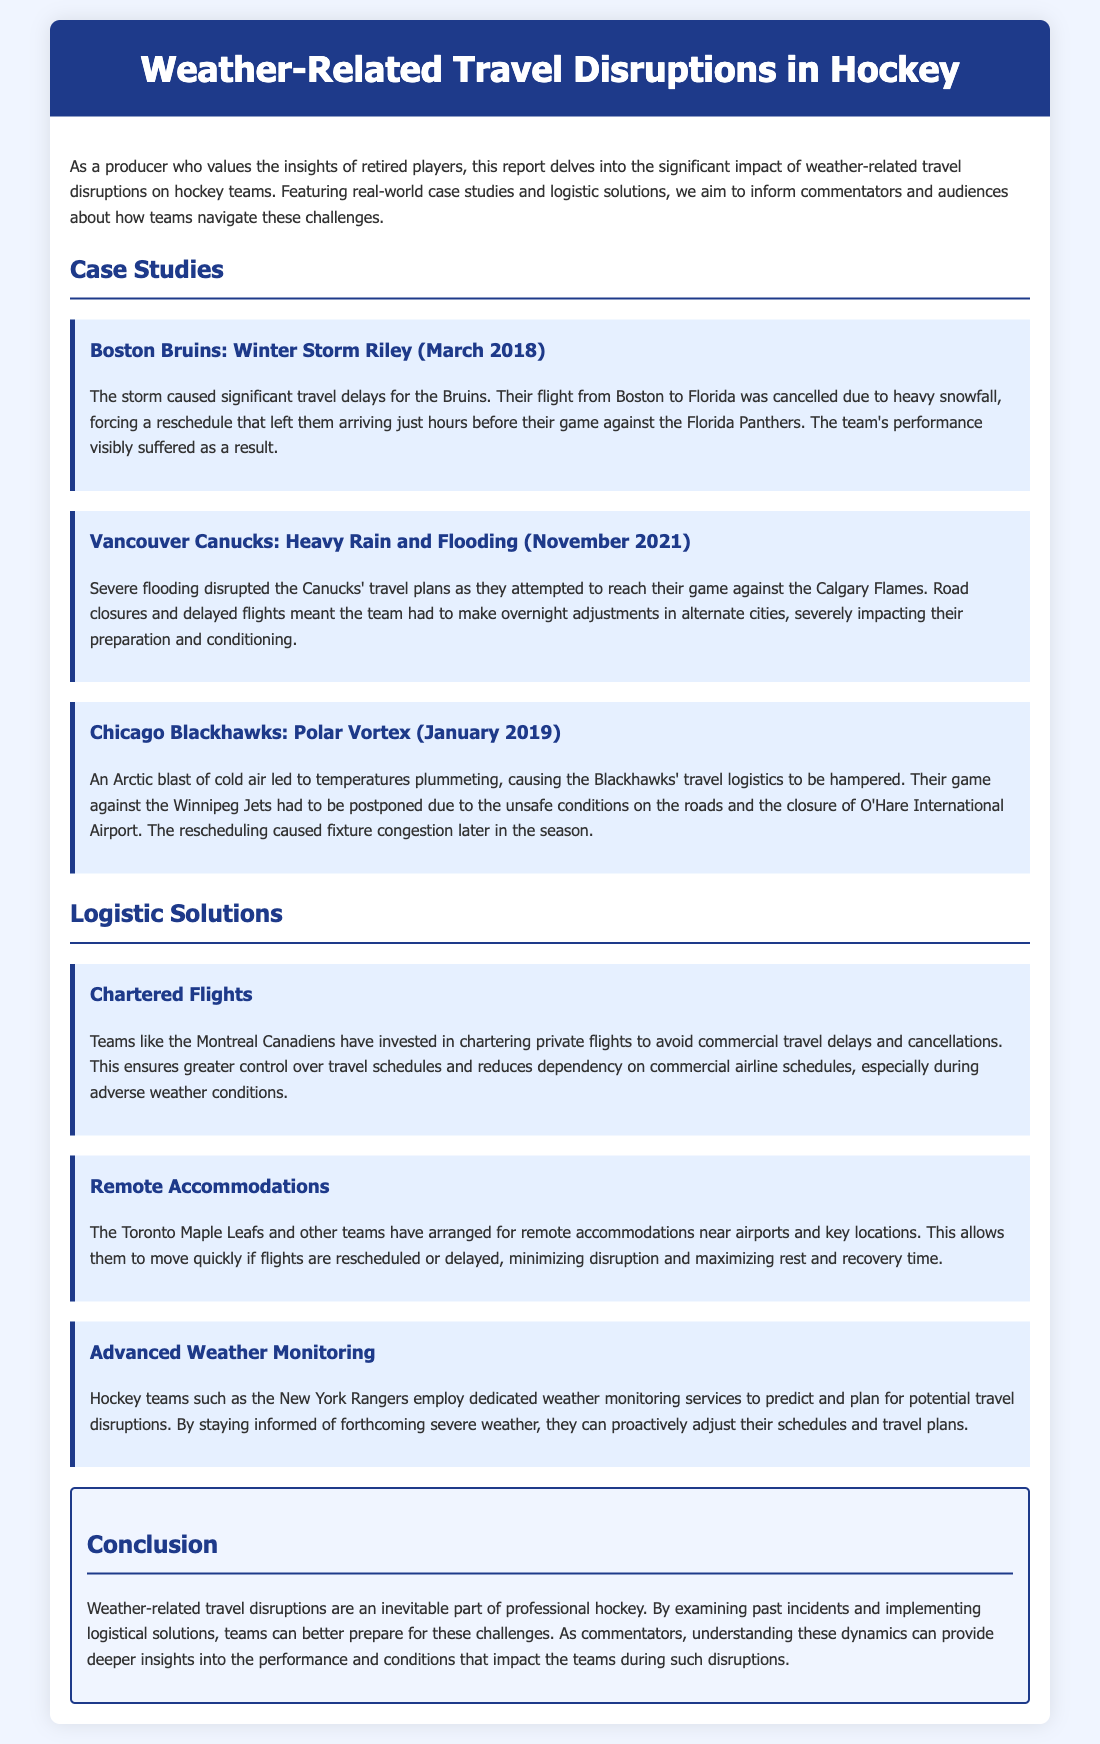What team faced travel disruptions due to Winter Storm Riley? The Boston Bruins experienced travel disruptions as a result of Winter Storm Riley in March 2018.
Answer: Boston Bruins What caused the Blackhawks' game against the Jets to be postponed? The Chicago Blackhawks' game was postponed due to unsafe conditions on the roads and the closure of O'Hare International Airport caused by the Polar Vortex.
Answer: Polar Vortex Which team arranged remote accommodations near airports? The Toronto Maple Leafs made arrangements for remote accommodations to minimize disruptions.
Answer: Toronto Maple Leafs What month and year did the Vancouver Canucks face travel disruptions? The Vancouver Canucks faced travel disruptions in November 2021 due to severe flooding.
Answer: November 2021 What logistic solution involves private flights? Chartering private flights is the logistic solution that teams like the Montreal Canadiens use to avoid delays.
Answer: Chartered Flights How do hockey teams monitor severe weather? The New York Rangers use dedicated weather monitoring services to predict and plan for potential travel disruptions.
Answer: Advanced Weather Monitoring What weather event disrupted the Canucks' travel plans? Severe flooding significantly disrupted the Vancouver Canucks' travel plans.
Answer: Heavy Rain and Flooding What is a significant impact of weather-related disruptions on teams? Weather-related travel disruptions can visibly affect team performance during games.
Answer: Team performance Which month and year did the travel disruption for the Bruins occur? The travel disruption for the Boston Bruins occurred in March 2018.
Answer: March 2018 